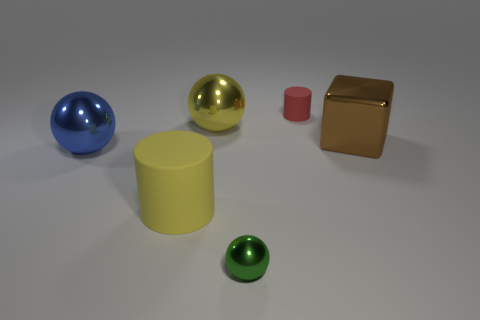Add 3 green spheres. How many objects exist? 9 Subtract all cubes. How many objects are left? 5 Subtract 0 red spheres. How many objects are left? 6 Subtract all small red matte cylinders. Subtract all big metal blocks. How many objects are left? 4 Add 6 tiny green objects. How many tiny green objects are left? 7 Add 4 big brown shiny spheres. How many big brown shiny spheres exist? 4 